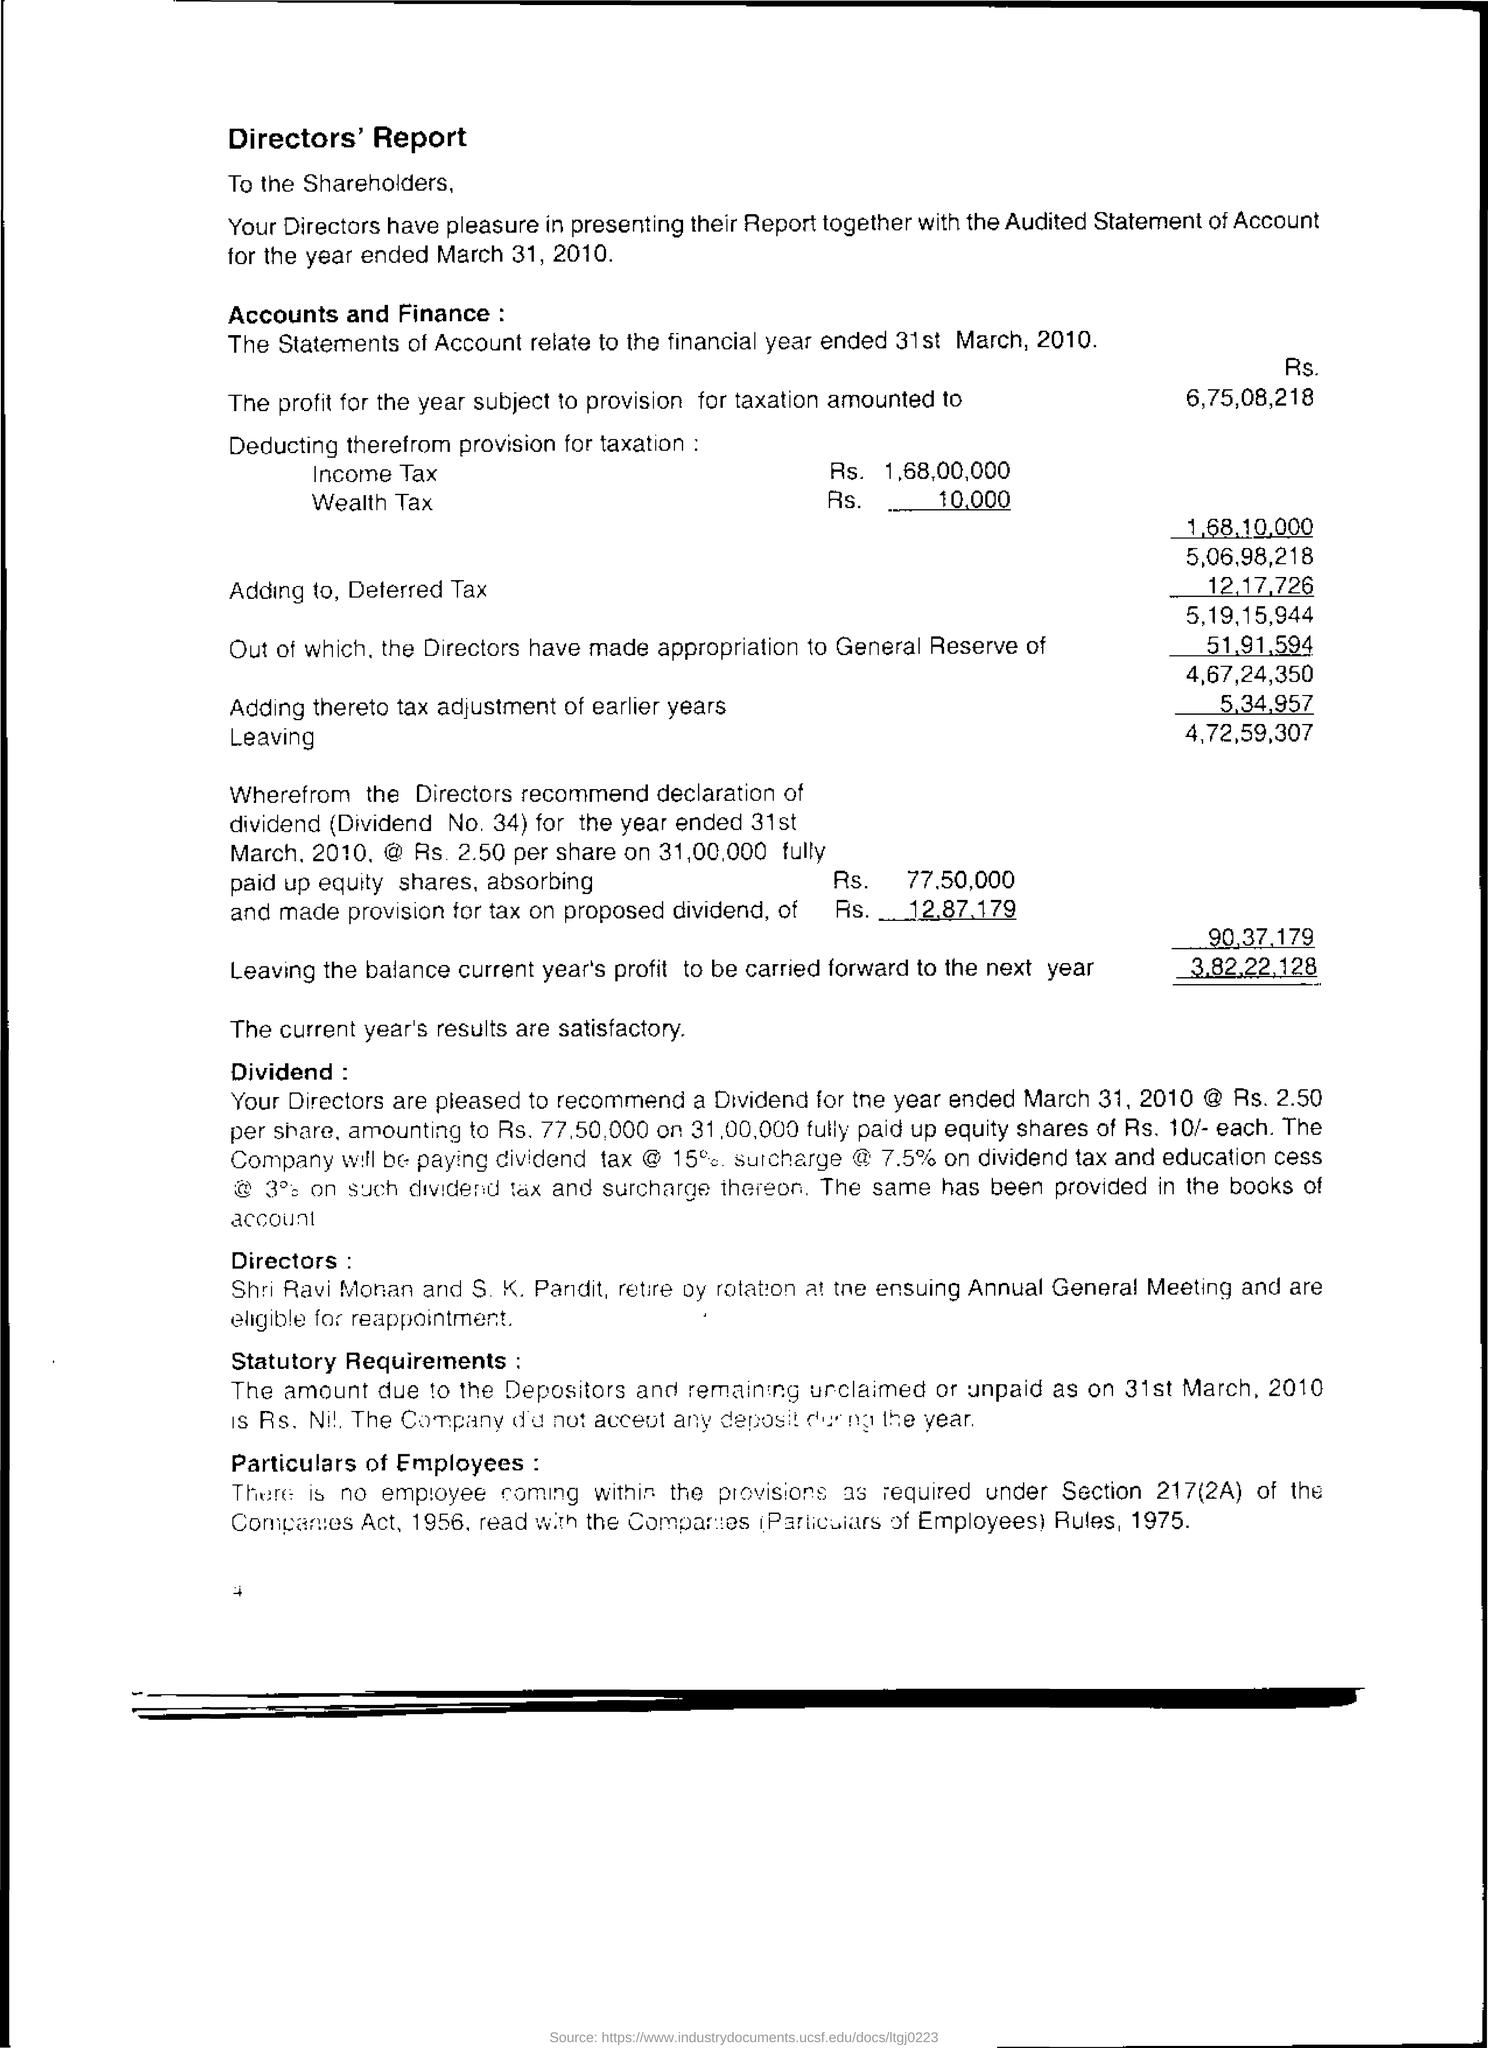Identify some key points in this picture. The Directors sent the report to the shareholders. 